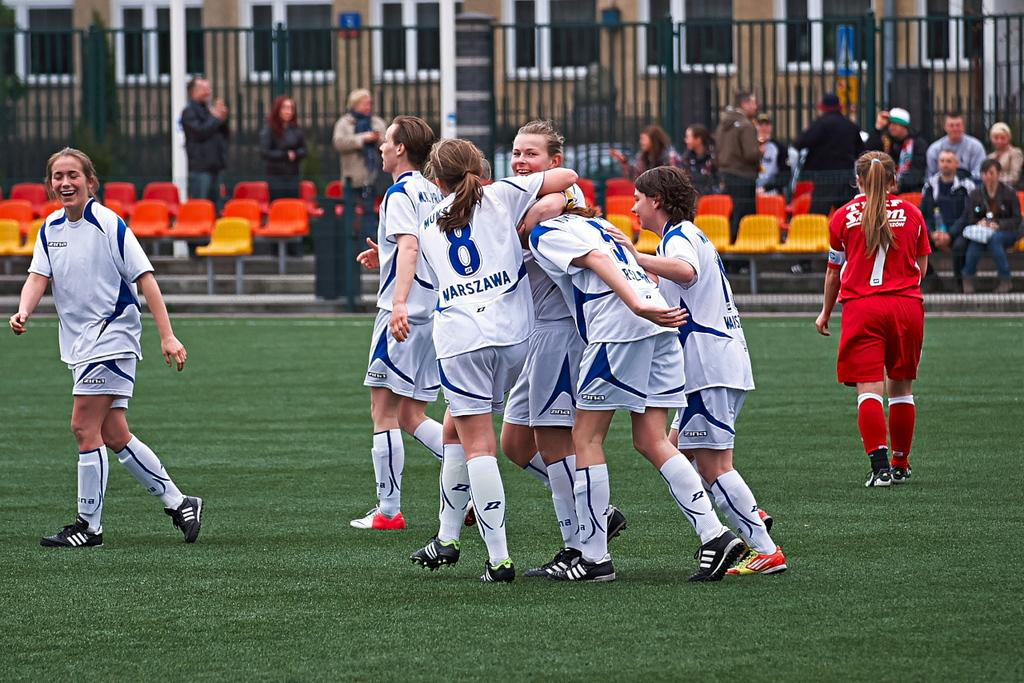What are the people in the image doing? The people in the image are in motion, which suggests they might be walking or running. What type of natural environment is visible in the image? There is grass visible in the image, indicating that the scene takes place in an outdoor setting. What can be seen in the background of the image? In the background of the image, there are chairs, people, a fence, windows, and poles. How many elements can be identified in the background of the image? There are six elements present in the background: chairs, people, a fence, windows, and poles. What type of texture can be seen on the beef in the image? There is no beef present in the image, so it is not possible to determine the texture of any beef. 